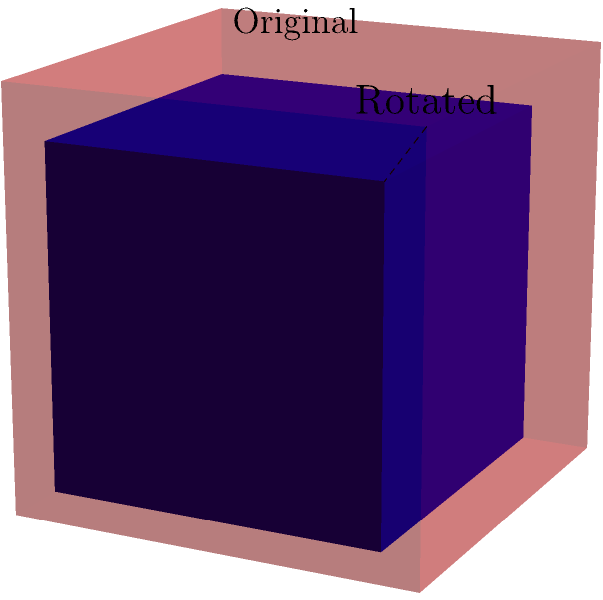In a 3D game engine, you're implementing a character rotation system. The rotation group of the character model is isomorphic to $SO(3)$, the special orthogonal group in three dimensions. If you apply a rotation of $120^\circ$ around the axis $(1,1,1)$, what is the order of this rotation in the group? Let's approach this step-by-step:

1) First, recall that the order of an element in a group is the smallest positive integer $n$ such that $g^n = e$, where $e$ is the identity element.

2) In the context of 3D rotations, this means we need to find how many times we need to apply this rotation to get back to the starting position.

3) The rotation is $120^\circ$ (or $\frac{2\pi}{3}$ radians) around the axis $(1,1,1)$.

4) Let's consider what happens when we apply this rotation multiple times:
   - 1 rotation: $120^\circ$
   - 2 rotations: $240^\circ$
   - 3 rotations: $360^\circ = 0^\circ$ (back to starting position)

5) After 3 rotations, we're back where we started, which means the identity transformation has been reached.

6) Therefore, the order of this rotation in the group is 3.

This result is consistent with the fact that $120^\circ$ is one-third of a full rotation, so it takes three applications to complete a full rotation.
Answer: 3 